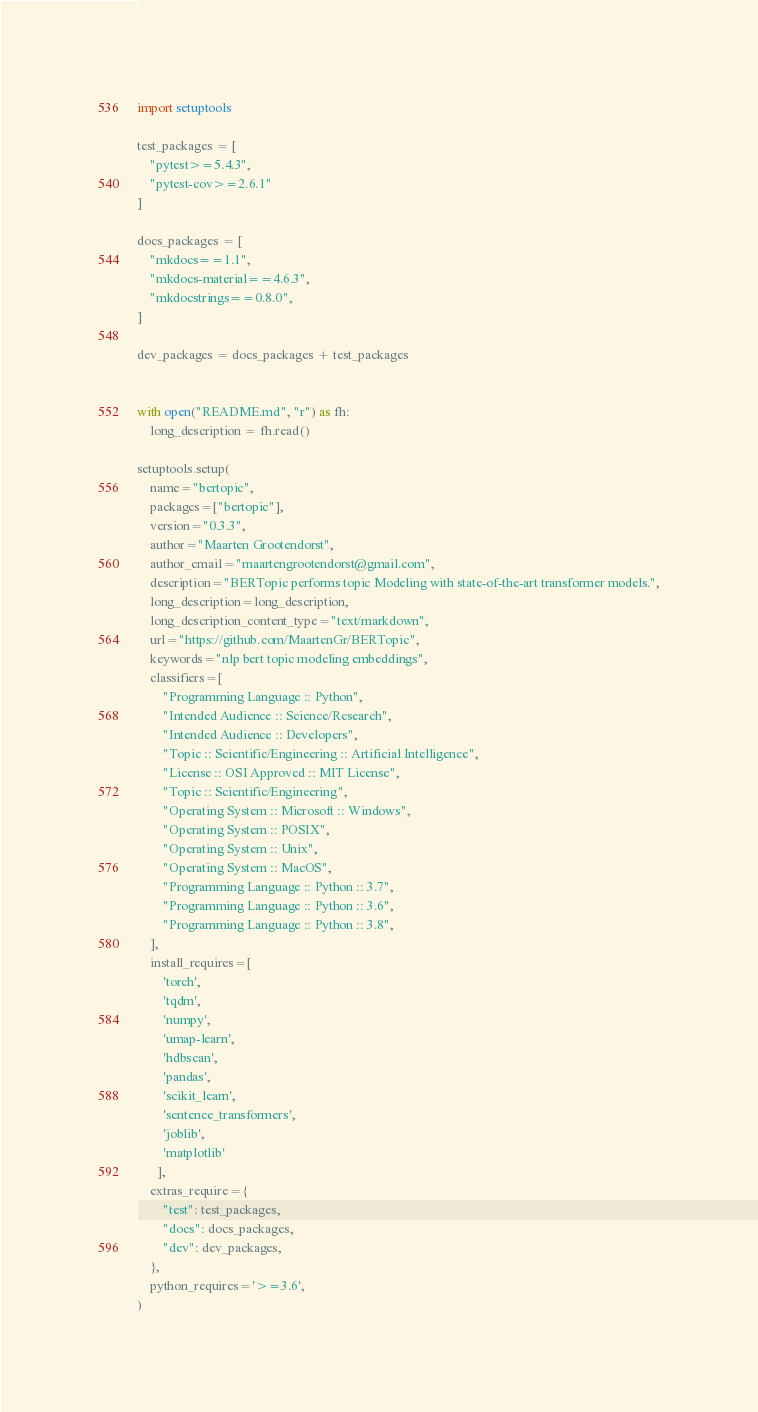<code> <loc_0><loc_0><loc_500><loc_500><_Python_>import setuptools

test_packages = [
    "pytest>=5.4.3",
    "pytest-cov>=2.6.1"
]

docs_packages = [
    "mkdocs==1.1",
    "mkdocs-material==4.6.3",
    "mkdocstrings==0.8.0",
]

dev_packages = docs_packages + test_packages


with open("README.md", "r") as fh:
    long_description = fh.read()

setuptools.setup(
    name="bertopic",
    packages=["bertopic"],
    version="0.3.3",
    author="Maarten Grootendorst",
    author_email="maartengrootendorst@gmail.com",
    description="BERTopic performs topic Modeling with state-of-the-art transformer models.",
    long_description=long_description,
    long_description_content_type="text/markdown",
    url="https://github.com/MaartenGr/BERTopic",
    keywords="nlp bert topic modeling embeddings",
    classifiers=[
        "Programming Language :: Python",
        "Intended Audience :: Science/Research",
        "Intended Audience :: Developers",
        "Topic :: Scientific/Engineering :: Artificial Intelligence",
        "License :: OSI Approved :: MIT License",
        "Topic :: Scientific/Engineering",
        "Operating System :: Microsoft :: Windows",
        "Operating System :: POSIX",
        "Operating System :: Unix",
        "Operating System :: MacOS",
        "Programming Language :: Python :: 3.7",
        "Programming Language :: Python :: 3.6",
        "Programming Language :: Python :: 3.8",
    ],
    install_requires=[
        'torch',
        'tqdm',
        'numpy',
        'umap-learn',
        'hdbscan',
        'pandas',
        'scikit_learn',
        'sentence_transformers',
        'joblib',
        'matplotlib'
      ],
    extras_require={
        "test": test_packages,
        "docs": docs_packages,
        "dev": dev_packages,
    },
    python_requires='>=3.6',
)</code> 